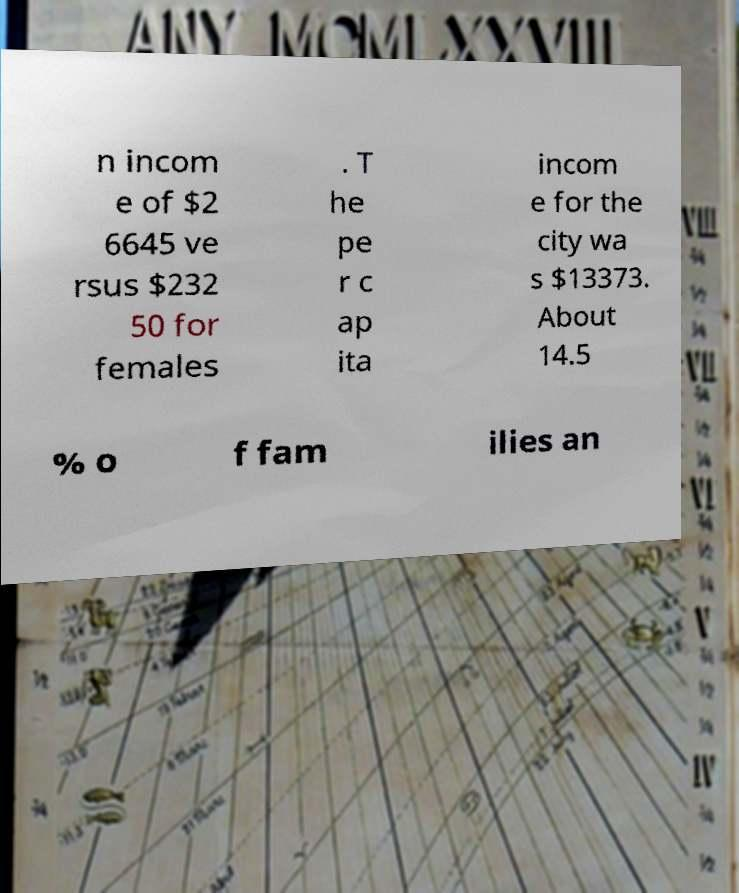Could you extract and type out the text from this image? n incom e of $2 6645 ve rsus $232 50 for females . T he pe r c ap ita incom e for the city wa s $13373. About 14.5 % o f fam ilies an 